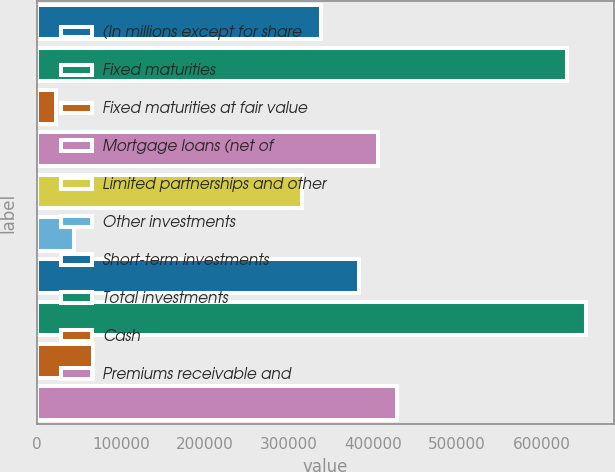<chart> <loc_0><loc_0><loc_500><loc_500><bar_chart><fcel>(In millions except for share<fcel>Fixed maturities<fcel>Fixed maturities at fair value<fcel>Mortgage loans (net of<fcel>Limited partnerships and other<fcel>Other investments<fcel>Short-term investments<fcel>Total investments<fcel>Cash<fcel>Premiums receivable and<nl><fcel>337888<fcel>630721<fcel>22529.6<fcel>405465<fcel>315362<fcel>45055.2<fcel>382939<fcel>653246<fcel>67580.8<fcel>427990<nl></chart> 